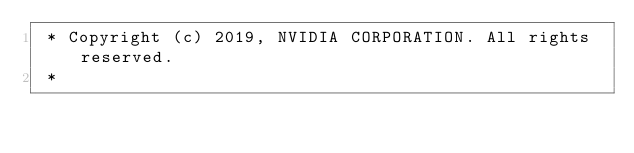Convert code to text. <code><loc_0><loc_0><loc_500><loc_500><_C++_> * Copyright (c) 2019, NVIDIA CORPORATION. All rights reserved.
 *</code> 